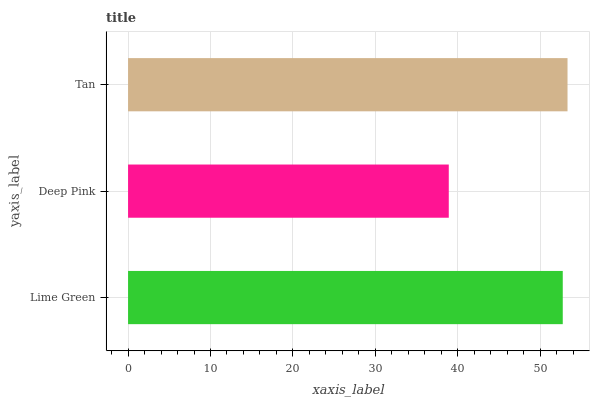Is Deep Pink the minimum?
Answer yes or no. Yes. Is Tan the maximum?
Answer yes or no. Yes. Is Tan the minimum?
Answer yes or no. No. Is Deep Pink the maximum?
Answer yes or no. No. Is Tan greater than Deep Pink?
Answer yes or no. Yes. Is Deep Pink less than Tan?
Answer yes or no. Yes. Is Deep Pink greater than Tan?
Answer yes or no. No. Is Tan less than Deep Pink?
Answer yes or no. No. Is Lime Green the high median?
Answer yes or no. Yes. Is Lime Green the low median?
Answer yes or no. Yes. Is Tan the high median?
Answer yes or no. No. Is Tan the low median?
Answer yes or no. No. 